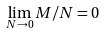Convert formula to latex. <formula><loc_0><loc_0><loc_500><loc_500>\lim _ { N \to 0 } M / N = 0</formula> 